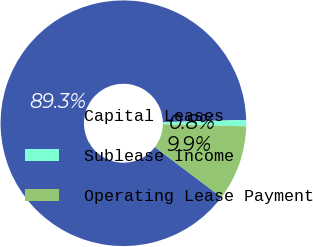Convert chart. <chart><loc_0><loc_0><loc_500><loc_500><pie_chart><fcel>Capital Leases<fcel>Sublease Income<fcel>Operating Lease Payment<nl><fcel>89.28%<fcel>0.83%<fcel>9.89%<nl></chart> 